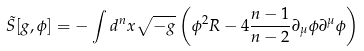<formula> <loc_0><loc_0><loc_500><loc_500>\tilde { S } [ g , \phi ] = - \int d ^ { n } x \sqrt { - g } \left ( \phi ^ { 2 } R - 4 \frac { n - 1 } { n - 2 } \partial _ { \mu } \phi \partial ^ { \mu } \phi \right ) \,</formula> 